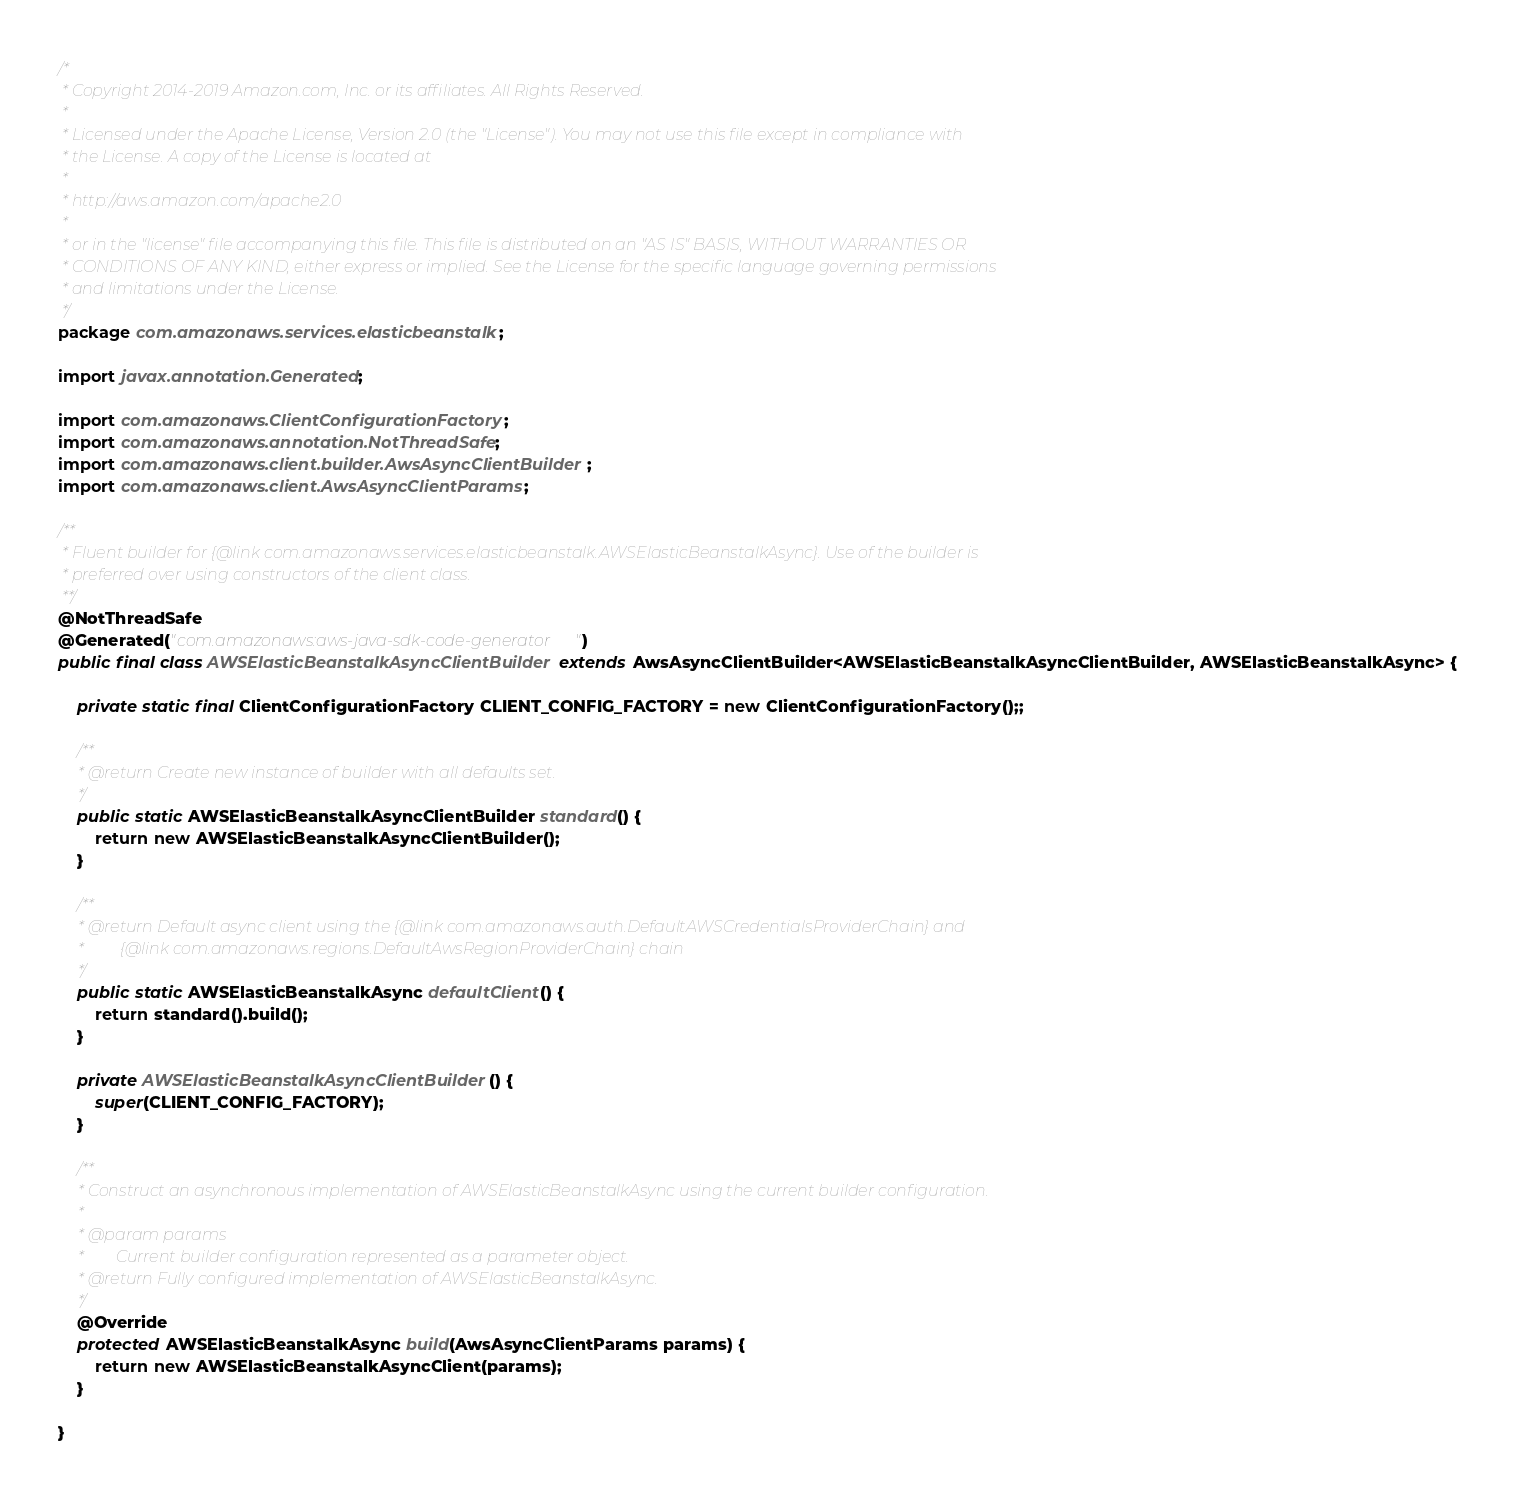Convert code to text. <code><loc_0><loc_0><loc_500><loc_500><_Java_>/*
 * Copyright 2014-2019 Amazon.com, Inc. or its affiliates. All Rights Reserved.
 * 
 * Licensed under the Apache License, Version 2.0 (the "License"). You may not use this file except in compliance with
 * the License. A copy of the License is located at
 * 
 * http://aws.amazon.com/apache2.0
 * 
 * or in the "license" file accompanying this file. This file is distributed on an "AS IS" BASIS, WITHOUT WARRANTIES OR
 * CONDITIONS OF ANY KIND, either express or implied. See the License for the specific language governing permissions
 * and limitations under the License.
 */
package com.amazonaws.services.elasticbeanstalk;

import javax.annotation.Generated;

import com.amazonaws.ClientConfigurationFactory;
import com.amazonaws.annotation.NotThreadSafe;
import com.amazonaws.client.builder.AwsAsyncClientBuilder;
import com.amazonaws.client.AwsAsyncClientParams;

/**
 * Fluent builder for {@link com.amazonaws.services.elasticbeanstalk.AWSElasticBeanstalkAsync}. Use of the builder is
 * preferred over using constructors of the client class.
 **/
@NotThreadSafe
@Generated("com.amazonaws:aws-java-sdk-code-generator")
public final class AWSElasticBeanstalkAsyncClientBuilder extends AwsAsyncClientBuilder<AWSElasticBeanstalkAsyncClientBuilder, AWSElasticBeanstalkAsync> {

    private static final ClientConfigurationFactory CLIENT_CONFIG_FACTORY = new ClientConfigurationFactory();;

    /**
     * @return Create new instance of builder with all defaults set.
     */
    public static AWSElasticBeanstalkAsyncClientBuilder standard() {
        return new AWSElasticBeanstalkAsyncClientBuilder();
    }

    /**
     * @return Default async client using the {@link com.amazonaws.auth.DefaultAWSCredentialsProviderChain} and
     *         {@link com.amazonaws.regions.DefaultAwsRegionProviderChain} chain
     */
    public static AWSElasticBeanstalkAsync defaultClient() {
        return standard().build();
    }

    private AWSElasticBeanstalkAsyncClientBuilder() {
        super(CLIENT_CONFIG_FACTORY);
    }

    /**
     * Construct an asynchronous implementation of AWSElasticBeanstalkAsync using the current builder configuration.
     *
     * @param params
     *        Current builder configuration represented as a parameter object.
     * @return Fully configured implementation of AWSElasticBeanstalkAsync.
     */
    @Override
    protected AWSElasticBeanstalkAsync build(AwsAsyncClientParams params) {
        return new AWSElasticBeanstalkAsyncClient(params);
    }

}
</code> 